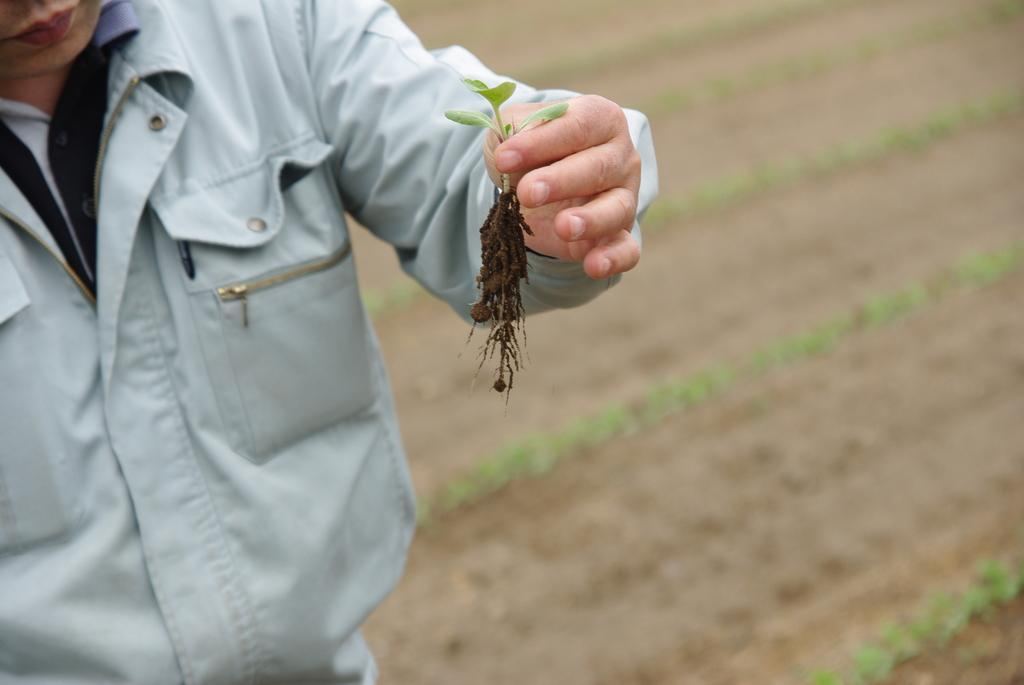What is the main subject of the image? There is a person in the image. What is the person doing in the image? The person is standing. What object is the person holding in the image? The person is holding a small plant. What type of crayon can be seen in the person's hand in the image? There is no crayon present in the image; the person is holding a small plant. Can you see any cobwebs in the image? There is no mention of cobwebs in the provided facts, so we cannot determine if any are present in the image. 